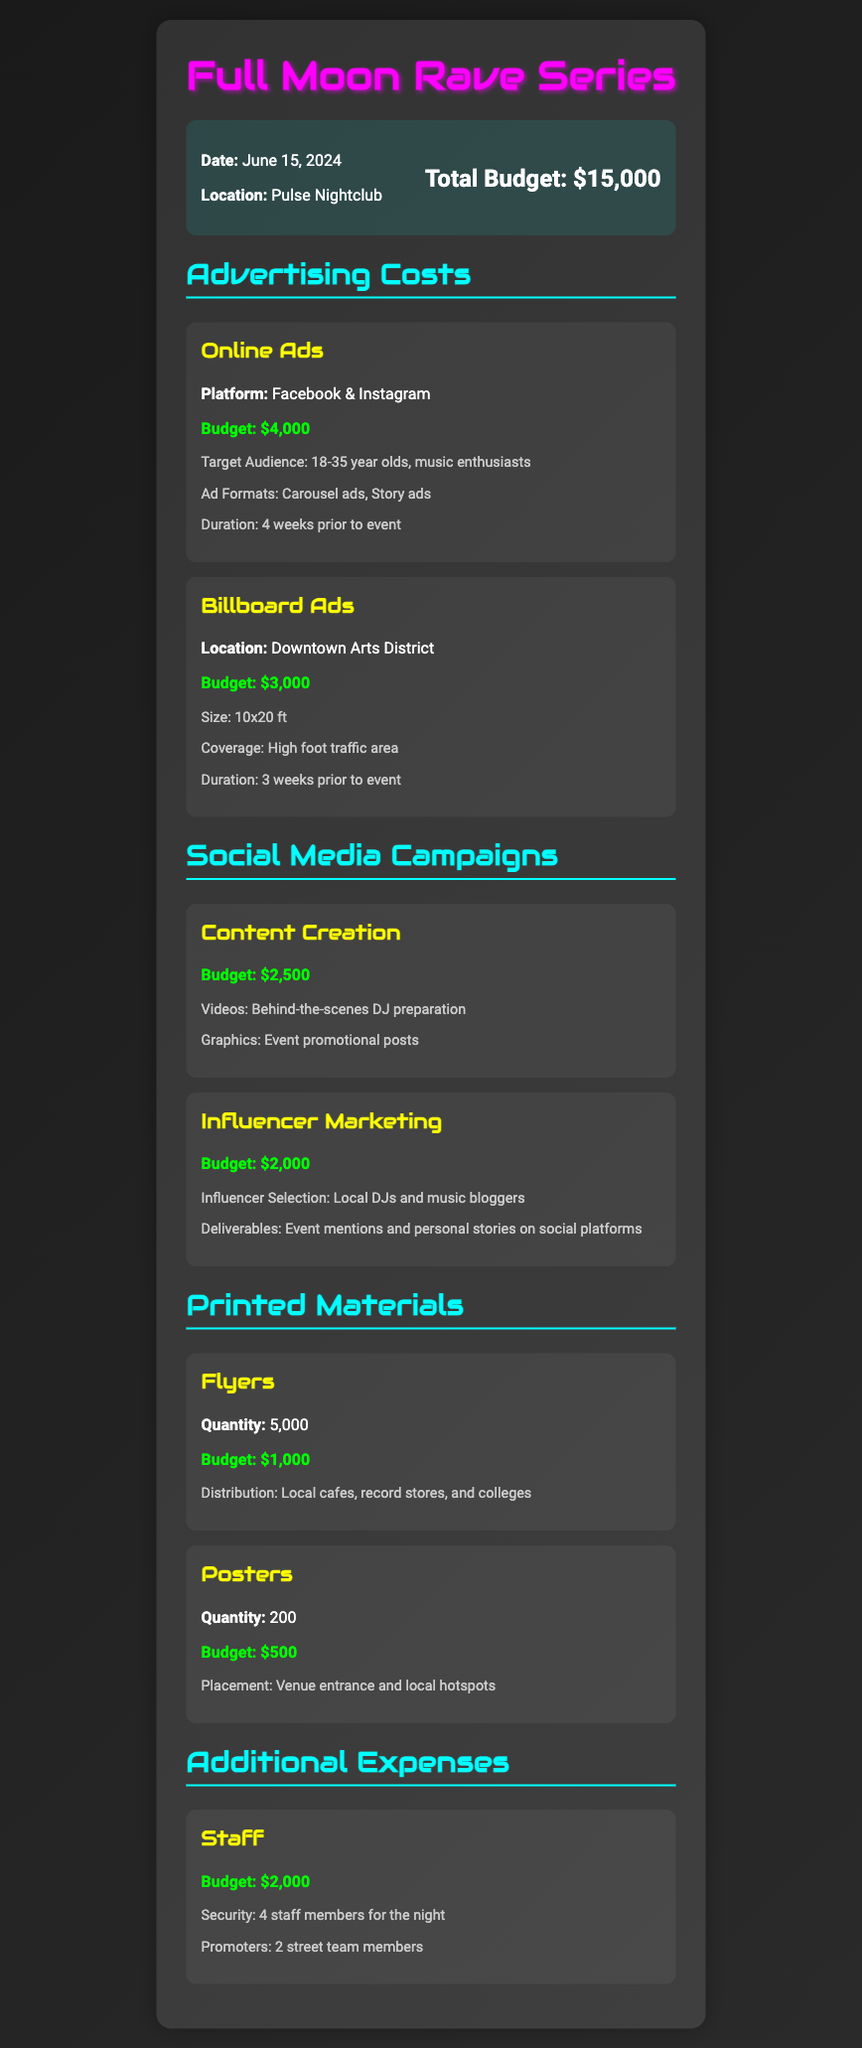What is the total budget for the event? The total budget is stated at the beginning of the document.
Answer: $15,000 When is the event scheduled? The date of the event is explicitly mentioned in the budget overview.
Answer: June 15, 2024 What is the budget allocated for online ads? The budget amount for online ads can be found under Advertising Costs.
Answer: $4,000 How many flyers are planned for distribution? The quantity of flyers is provided in the Printed Materials section.
Answer: 5,000 What is the budget for influencer marketing? The specific budget for influencer marketing is listed under Social Media Campaigns.
Answer: $2,000 What type of advertising is planned for the Downtown Arts District? The advertising type is specified in the Advertising Costs section related to location.
Answer: Billboard Ads Why is the budget for staff allocated? The document elaborates on the staffing need in the Additional Expenses category.
Answer: Security and promoters for the night What is the budget for printed posters? The budget amount for posters is mentioned in the Printed Materials section.
Answer: $500 How long will the online ads run before the event? The duration for the online ads is stated under the details of Online Ads.
Answer: 4 weeks 